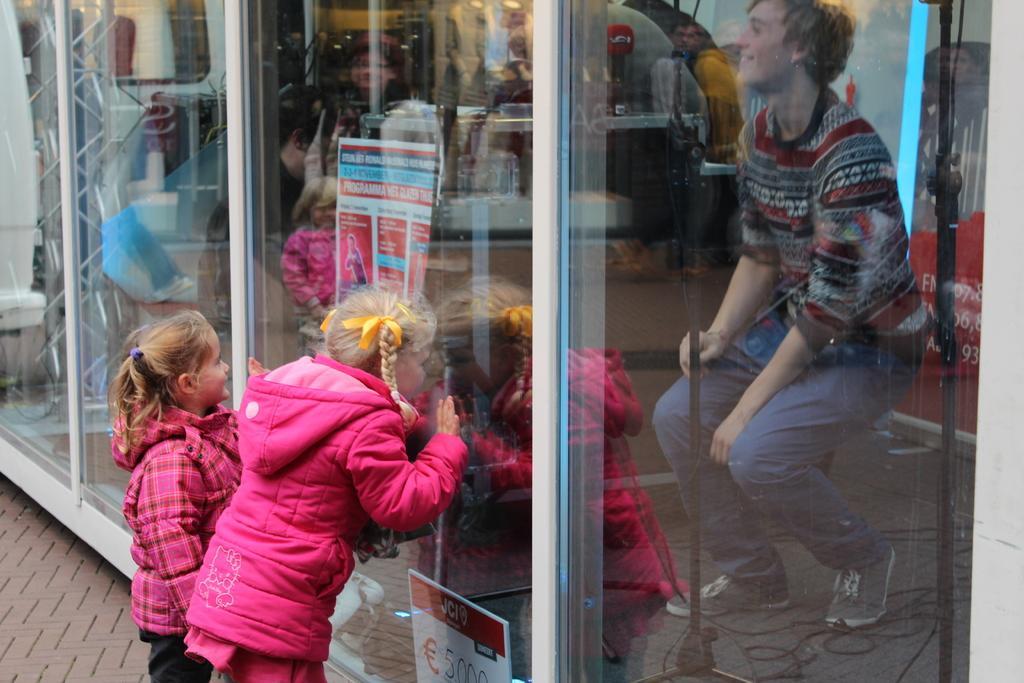Please provide a concise description of this image. This image consists of three persons. On the left, we can see two girls wearing pink jackets. At the bottom, there is a road. On the right, it looks like a shop in which there is a man sitting. And there are many things inside the shop. 